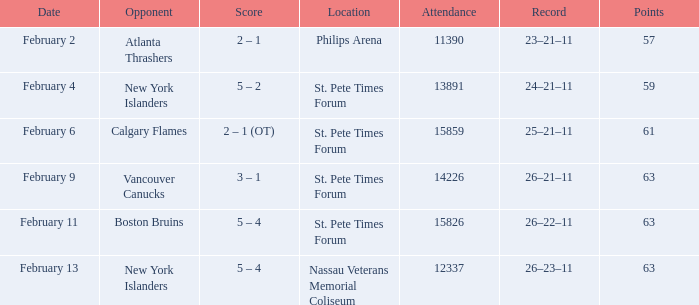Can you provide the scores from february 9? 3 – 1. 